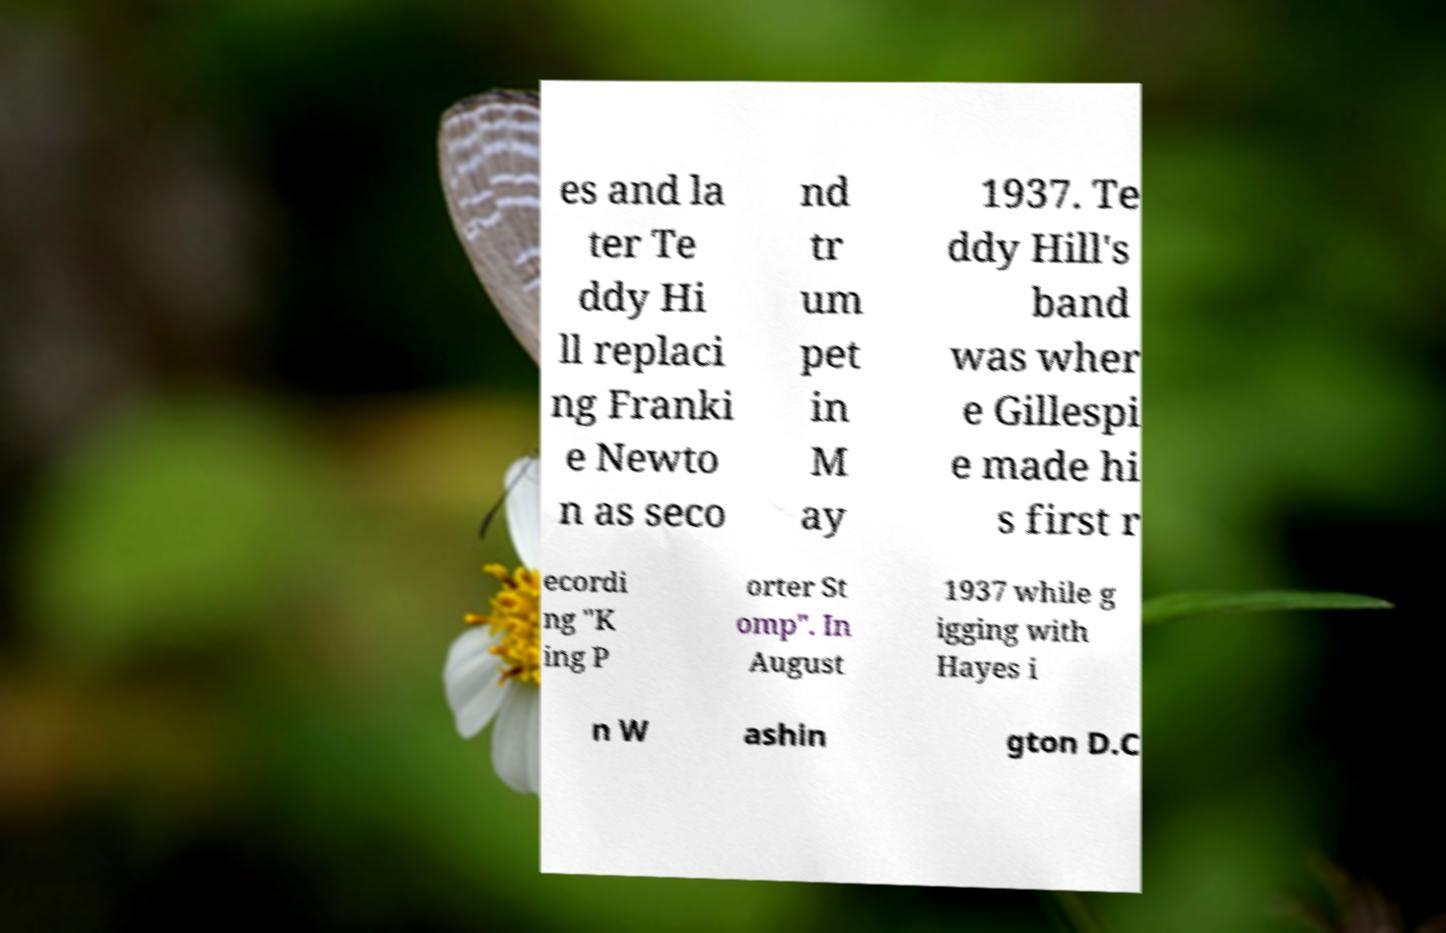There's text embedded in this image that I need extracted. Can you transcribe it verbatim? es and la ter Te ddy Hi ll replaci ng Franki e Newto n as seco nd tr um pet in M ay 1937. Te ddy Hill's band was wher e Gillespi e made hi s first r ecordi ng "K ing P orter St omp". In August 1937 while g igging with Hayes i n W ashin gton D.C 